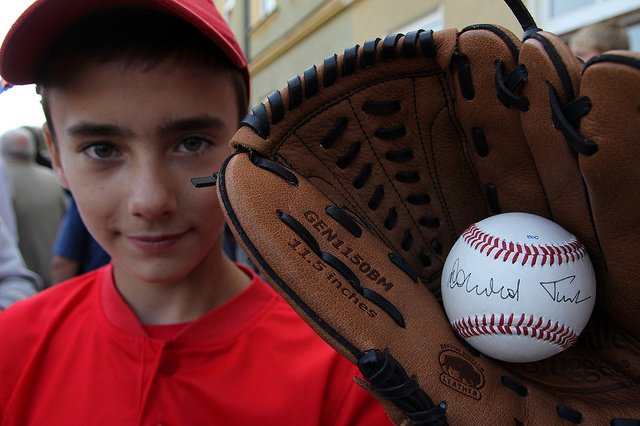<image>How big is the glove? I don't know how big the glove is. It can be small, big or average. How big is the glove? I don't know how big the glove is. It can be small, big, or average size. 